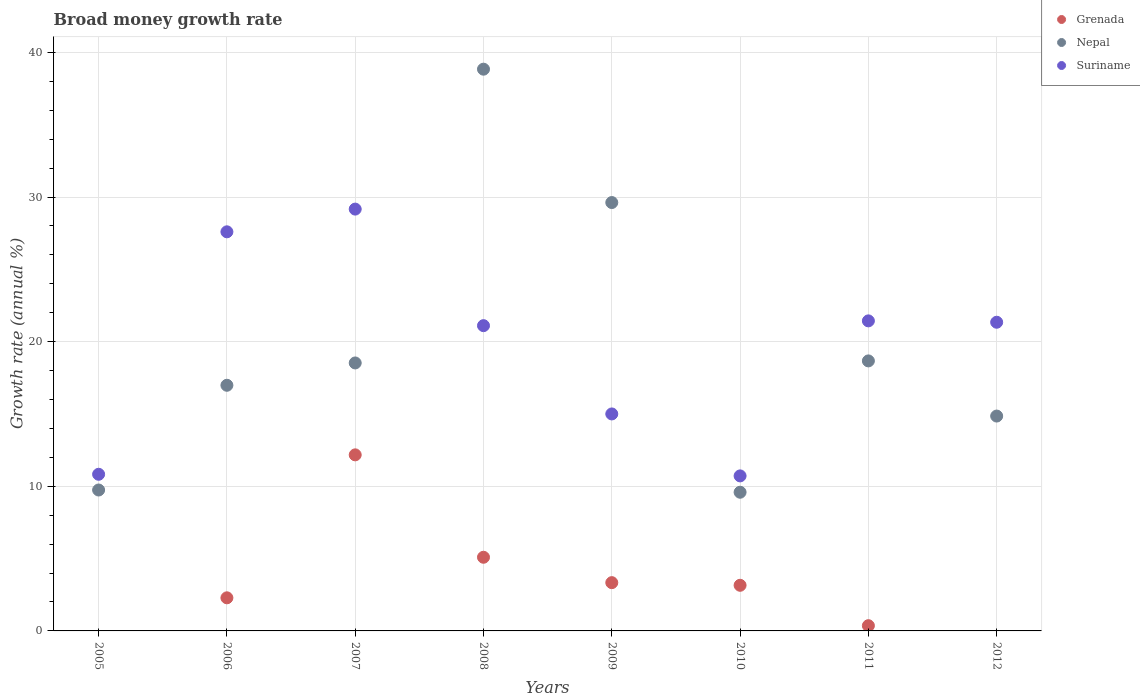Is the number of dotlines equal to the number of legend labels?
Offer a terse response. No. What is the growth rate in Nepal in 2005?
Provide a succinct answer. 9.74. Across all years, what is the maximum growth rate in Grenada?
Provide a short and direct response. 12.17. Across all years, what is the minimum growth rate in Grenada?
Keep it short and to the point. 0. In which year was the growth rate in Suriname maximum?
Offer a terse response. 2007. What is the total growth rate in Nepal in the graph?
Your answer should be compact. 156.83. What is the difference between the growth rate in Suriname in 2008 and that in 2009?
Make the answer very short. 6.1. What is the difference between the growth rate in Suriname in 2006 and the growth rate in Nepal in 2012?
Your answer should be compact. 12.74. What is the average growth rate in Suriname per year?
Keep it short and to the point. 19.65. In the year 2008, what is the difference between the growth rate in Suriname and growth rate in Grenada?
Your answer should be very brief. 16.01. In how many years, is the growth rate in Grenada greater than 20 %?
Ensure brevity in your answer.  0. What is the ratio of the growth rate in Suriname in 2007 to that in 2010?
Keep it short and to the point. 2.72. Is the growth rate in Nepal in 2005 less than that in 2012?
Ensure brevity in your answer.  Yes. What is the difference between the highest and the second highest growth rate in Nepal?
Provide a succinct answer. 9.22. What is the difference between the highest and the lowest growth rate in Grenada?
Your answer should be very brief. 12.17. In how many years, is the growth rate in Grenada greater than the average growth rate in Grenada taken over all years?
Your answer should be compact. 3. Is the sum of the growth rate in Grenada in 2007 and 2011 greater than the maximum growth rate in Suriname across all years?
Your answer should be very brief. No. Is it the case that in every year, the sum of the growth rate in Nepal and growth rate in Suriname  is greater than the growth rate in Grenada?
Your answer should be very brief. Yes. Does the growth rate in Nepal monotonically increase over the years?
Offer a terse response. No. Is the growth rate in Nepal strictly greater than the growth rate in Grenada over the years?
Give a very brief answer. Yes. Does the graph contain any zero values?
Your response must be concise. Yes. Where does the legend appear in the graph?
Provide a short and direct response. Top right. How many legend labels are there?
Your answer should be compact. 3. How are the legend labels stacked?
Offer a very short reply. Vertical. What is the title of the graph?
Your answer should be compact. Broad money growth rate. What is the label or title of the X-axis?
Offer a terse response. Years. What is the label or title of the Y-axis?
Your answer should be compact. Growth rate (annual %). What is the Growth rate (annual %) in Grenada in 2005?
Provide a short and direct response. 0. What is the Growth rate (annual %) in Nepal in 2005?
Give a very brief answer. 9.74. What is the Growth rate (annual %) of Suriname in 2005?
Offer a terse response. 10.83. What is the Growth rate (annual %) in Grenada in 2006?
Ensure brevity in your answer.  2.29. What is the Growth rate (annual %) in Nepal in 2006?
Ensure brevity in your answer.  16.99. What is the Growth rate (annual %) of Suriname in 2006?
Give a very brief answer. 27.6. What is the Growth rate (annual %) in Grenada in 2007?
Offer a very short reply. 12.17. What is the Growth rate (annual %) in Nepal in 2007?
Offer a terse response. 18.53. What is the Growth rate (annual %) of Suriname in 2007?
Your response must be concise. 29.17. What is the Growth rate (annual %) of Grenada in 2008?
Give a very brief answer. 5.09. What is the Growth rate (annual %) of Nepal in 2008?
Your answer should be very brief. 38.84. What is the Growth rate (annual %) of Suriname in 2008?
Your answer should be very brief. 21.11. What is the Growth rate (annual %) in Grenada in 2009?
Make the answer very short. 3.34. What is the Growth rate (annual %) in Nepal in 2009?
Your answer should be very brief. 29.62. What is the Growth rate (annual %) in Suriname in 2009?
Provide a succinct answer. 15. What is the Growth rate (annual %) in Grenada in 2010?
Your response must be concise. 3.15. What is the Growth rate (annual %) in Nepal in 2010?
Make the answer very short. 9.59. What is the Growth rate (annual %) of Suriname in 2010?
Make the answer very short. 10.72. What is the Growth rate (annual %) of Grenada in 2011?
Your answer should be compact. 0.36. What is the Growth rate (annual %) in Nepal in 2011?
Your answer should be compact. 18.67. What is the Growth rate (annual %) in Suriname in 2011?
Offer a very short reply. 21.44. What is the Growth rate (annual %) in Nepal in 2012?
Ensure brevity in your answer.  14.86. What is the Growth rate (annual %) of Suriname in 2012?
Your answer should be very brief. 21.34. Across all years, what is the maximum Growth rate (annual %) of Grenada?
Your answer should be compact. 12.17. Across all years, what is the maximum Growth rate (annual %) in Nepal?
Your answer should be compact. 38.84. Across all years, what is the maximum Growth rate (annual %) of Suriname?
Your answer should be very brief. 29.17. Across all years, what is the minimum Growth rate (annual %) of Grenada?
Ensure brevity in your answer.  0. Across all years, what is the minimum Growth rate (annual %) of Nepal?
Offer a terse response. 9.59. Across all years, what is the minimum Growth rate (annual %) of Suriname?
Provide a succinct answer. 10.72. What is the total Growth rate (annual %) of Grenada in the graph?
Ensure brevity in your answer.  26.41. What is the total Growth rate (annual %) of Nepal in the graph?
Your answer should be compact. 156.83. What is the total Growth rate (annual %) in Suriname in the graph?
Provide a succinct answer. 157.2. What is the difference between the Growth rate (annual %) of Nepal in 2005 and that in 2006?
Your answer should be very brief. -7.24. What is the difference between the Growth rate (annual %) in Suriname in 2005 and that in 2006?
Make the answer very short. -16.76. What is the difference between the Growth rate (annual %) in Nepal in 2005 and that in 2007?
Your answer should be very brief. -8.79. What is the difference between the Growth rate (annual %) in Suriname in 2005 and that in 2007?
Your answer should be very brief. -18.34. What is the difference between the Growth rate (annual %) in Nepal in 2005 and that in 2008?
Give a very brief answer. -29.1. What is the difference between the Growth rate (annual %) in Suriname in 2005 and that in 2008?
Offer a very short reply. -10.28. What is the difference between the Growth rate (annual %) of Nepal in 2005 and that in 2009?
Keep it short and to the point. -19.88. What is the difference between the Growth rate (annual %) in Suriname in 2005 and that in 2009?
Your answer should be very brief. -4.17. What is the difference between the Growth rate (annual %) in Nepal in 2005 and that in 2010?
Keep it short and to the point. 0.15. What is the difference between the Growth rate (annual %) in Suriname in 2005 and that in 2010?
Ensure brevity in your answer.  0.11. What is the difference between the Growth rate (annual %) of Nepal in 2005 and that in 2011?
Ensure brevity in your answer.  -8.93. What is the difference between the Growth rate (annual %) in Suriname in 2005 and that in 2011?
Your answer should be very brief. -10.61. What is the difference between the Growth rate (annual %) of Nepal in 2005 and that in 2012?
Provide a succinct answer. -5.11. What is the difference between the Growth rate (annual %) in Suriname in 2005 and that in 2012?
Provide a succinct answer. -10.51. What is the difference between the Growth rate (annual %) of Grenada in 2006 and that in 2007?
Give a very brief answer. -9.88. What is the difference between the Growth rate (annual %) in Nepal in 2006 and that in 2007?
Ensure brevity in your answer.  -1.54. What is the difference between the Growth rate (annual %) of Suriname in 2006 and that in 2007?
Your answer should be compact. -1.57. What is the difference between the Growth rate (annual %) of Grenada in 2006 and that in 2008?
Your answer should be compact. -2.8. What is the difference between the Growth rate (annual %) in Nepal in 2006 and that in 2008?
Make the answer very short. -21.86. What is the difference between the Growth rate (annual %) of Suriname in 2006 and that in 2008?
Provide a short and direct response. 6.49. What is the difference between the Growth rate (annual %) of Grenada in 2006 and that in 2009?
Your answer should be compact. -1.05. What is the difference between the Growth rate (annual %) of Nepal in 2006 and that in 2009?
Give a very brief answer. -12.63. What is the difference between the Growth rate (annual %) in Suriname in 2006 and that in 2009?
Give a very brief answer. 12.59. What is the difference between the Growth rate (annual %) in Grenada in 2006 and that in 2010?
Provide a succinct answer. -0.87. What is the difference between the Growth rate (annual %) in Nepal in 2006 and that in 2010?
Make the answer very short. 7.4. What is the difference between the Growth rate (annual %) in Suriname in 2006 and that in 2010?
Give a very brief answer. 16.88. What is the difference between the Growth rate (annual %) in Grenada in 2006 and that in 2011?
Provide a short and direct response. 1.93. What is the difference between the Growth rate (annual %) in Nepal in 2006 and that in 2011?
Give a very brief answer. -1.69. What is the difference between the Growth rate (annual %) in Suriname in 2006 and that in 2011?
Provide a succinct answer. 6.16. What is the difference between the Growth rate (annual %) of Nepal in 2006 and that in 2012?
Your response must be concise. 2.13. What is the difference between the Growth rate (annual %) in Suriname in 2006 and that in 2012?
Your response must be concise. 6.25. What is the difference between the Growth rate (annual %) of Grenada in 2007 and that in 2008?
Provide a short and direct response. 7.08. What is the difference between the Growth rate (annual %) of Nepal in 2007 and that in 2008?
Give a very brief answer. -20.31. What is the difference between the Growth rate (annual %) in Suriname in 2007 and that in 2008?
Your response must be concise. 8.06. What is the difference between the Growth rate (annual %) in Grenada in 2007 and that in 2009?
Provide a succinct answer. 8.84. What is the difference between the Growth rate (annual %) in Nepal in 2007 and that in 2009?
Offer a very short reply. -11.09. What is the difference between the Growth rate (annual %) in Suriname in 2007 and that in 2009?
Provide a succinct answer. 14.16. What is the difference between the Growth rate (annual %) in Grenada in 2007 and that in 2010?
Your answer should be very brief. 9.02. What is the difference between the Growth rate (annual %) in Nepal in 2007 and that in 2010?
Your answer should be compact. 8.94. What is the difference between the Growth rate (annual %) in Suriname in 2007 and that in 2010?
Give a very brief answer. 18.45. What is the difference between the Growth rate (annual %) of Grenada in 2007 and that in 2011?
Your answer should be compact. 11.81. What is the difference between the Growth rate (annual %) in Nepal in 2007 and that in 2011?
Your answer should be very brief. -0.14. What is the difference between the Growth rate (annual %) in Suriname in 2007 and that in 2011?
Provide a short and direct response. 7.73. What is the difference between the Growth rate (annual %) in Nepal in 2007 and that in 2012?
Your answer should be compact. 3.67. What is the difference between the Growth rate (annual %) of Suriname in 2007 and that in 2012?
Make the answer very short. 7.82. What is the difference between the Growth rate (annual %) of Grenada in 2008 and that in 2009?
Make the answer very short. 1.76. What is the difference between the Growth rate (annual %) of Nepal in 2008 and that in 2009?
Keep it short and to the point. 9.22. What is the difference between the Growth rate (annual %) in Suriname in 2008 and that in 2009?
Offer a very short reply. 6.1. What is the difference between the Growth rate (annual %) of Grenada in 2008 and that in 2010?
Make the answer very short. 1.94. What is the difference between the Growth rate (annual %) of Nepal in 2008 and that in 2010?
Your answer should be very brief. 29.25. What is the difference between the Growth rate (annual %) of Suriname in 2008 and that in 2010?
Ensure brevity in your answer.  10.39. What is the difference between the Growth rate (annual %) in Grenada in 2008 and that in 2011?
Provide a succinct answer. 4.73. What is the difference between the Growth rate (annual %) in Nepal in 2008 and that in 2011?
Offer a very short reply. 20.17. What is the difference between the Growth rate (annual %) of Suriname in 2008 and that in 2011?
Offer a terse response. -0.33. What is the difference between the Growth rate (annual %) in Nepal in 2008 and that in 2012?
Your answer should be very brief. 23.98. What is the difference between the Growth rate (annual %) of Suriname in 2008 and that in 2012?
Make the answer very short. -0.24. What is the difference between the Growth rate (annual %) of Grenada in 2009 and that in 2010?
Offer a terse response. 0.18. What is the difference between the Growth rate (annual %) in Nepal in 2009 and that in 2010?
Your response must be concise. 20.03. What is the difference between the Growth rate (annual %) of Suriname in 2009 and that in 2010?
Offer a terse response. 4.28. What is the difference between the Growth rate (annual %) in Grenada in 2009 and that in 2011?
Offer a very short reply. 2.98. What is the difference between the Growth rate (annual %) of Nepal in 2009 and that in 2011?
Offer a very short reply. 10.95. What is the difference between the Growth rate (annual %) in Suriname in 2009 and that in 2011?
Offer a very short reply. -6.43. What is the difference between the Growth rate (annual %) of Nepal in 2009 and that in 2012?
Offer a very short reply. 14.76. What is the difference between the Growth rate (annual %) of Suriname in 2009 and that in 2012?
Keep it short and to the point. -6.34. What is the difference between the Growth rate (annual %) of Grenada in 2010 and that in 2011?
Ensure brevity in your answer.  2.79. What is the difference between the Growth rate (annual %) in Nepal in 2010 and that in 2011?
Provide a short and direct response. -9.08. What is the difference between the Growth rate (annual %) in Suriname in 2010 and that in 2011?
Your response must be concise. -10.72. What is the difference between the Growth rate (annual %) in Nepal in 2010 and that in 2012?
Provide a short and direct response. -5.27. What is the difference between the Growth rate (annual %) of Suriname in 2010 and that in 2012?
Provide a short and direct response. -10.62. What is the difference between the Growth rate (annual %) of Nepal in 2011 and that in 2012?
Keep it short and to the point. 3.81. What is the difference between the Growth rate (annual %) of Suriname in 2011 and that in 2012?
Offer a terse response. 0.09. What is the difference between the Growth rate (annual %) of Nepal in 2005 and the Growth rate (annual %) of Suriname in 2006?
Your response must be concise. -17.85. What is the difference between the Growth rate (annual %) of Nepal in 2005 and the Growth rate (annual %) of Suriname in 2007?
Offer a very short reply. -19.42. What is the difference between the Growth rate (annual %) of Nepal in 2005 and the Growth rate (annual %) of Suriname in 2008?
Make the answer very short. -11.36. What is the difference between the Growth rate (annual %) in Nepal in 2005 and the Growth rate (annual %) in Suriname in 2009?
Keep it short and to the point. -5.26. What is the difference between the Growth rate (annual %) of Nepal in 2005 and the Growth rate (annual %) of Suriname in 2010?
Your answer should be very brief. -0.98. What is the difference between the Growth rate (annual %) in Nepal in 2005 and the Growth rate (annual %) in Suriname in 2011?
Provide a short and direct response. -11.69. What is the difference between the Growth rate (annual %) of Nepal in 2005 and the Growth rate (annual %) of Suriname in 2012?
Give a very brief answer. -11.6. What is the difference between the Growth rate (annual %) of Grenada in 2006 and the Growth rate (annual %) of Nepal in 2007?
Offer a terse response. -16.24. What is the difference between the Growth rate (annual %) of Grenada in 2006 and the Growth rate (annual %) of Suriname in 2007?
Your answer should be very brief. -26.88. What is the difference between the Growth rate (annual %) of Nepal in 2006 and the Growth rate (annual %) of Suriname in 2007?
Provide a succinct answer. -12.18. What is the difference between the Growth rate (annual %) of Grenada in 2006 and the Growth rate (annual %) of Nepal in 2008?
Ensure brevity in your answer.  -36.55. What is the difference between the Growth rate (annual %) of Grenada in 2006 and the Growth rate (annual %) of Suriname in 2008?
Ensure brevity in your answer.  -18.82. What is the difference between the Growth rate (annual %) of Nepal in 2006 and the Growth rate (annual %) of Suriname in 2008?
Offer a very short reply. -4.12. What is the difference between the Growth rate (annual %) of Grenada in 2006 and the Growth rate (annual %) of Nepal in 2009?
Your response must be concise. -27.33. What is the difference between the Growth rate (annual %) in Grenada in 2006 and the Growth rate (annual %) in Suriname in 2009?
Provide a short and direct response. -12.71. What is the difference between the Growth rate (annual %) in Nepal in 2006 and the Growth rate (annual %) in Suriname in 2009?
Make the answer very short. 1.98. What is the difference between the Growth rate (annual %) of Grenada in 2006 and the Growth rate (annual %) of Nepal in 2010?
Offer a very short reply. -7.3. What is the difference between the Growth rate (annual %) in Grenada in 2006 and the Growth rate (annual %) in Suriname in 2010?
Your answer should be very brief. -8.43. What is the difference between the Growth rate (annual %) in Nepal in 2006 and the Growth rate (annual %) in Suriname in 2010?
Offer a terse response. 6.27. What is the difference between the Growth rate (annual %) in Grenada in 2006 and the Growth rate (annual %) in Nepal in 2011?
Keep it short and to the point. -16.38. What is the difference between the Growth rate (annual %) of Grenada in 2006 and the Growth rate (annual %) of Suriname in 2011?
Make the answer very short. -19.15. What is the difference between the Growth rate (annual %) of Nepal in 2006 and the Growth rate (annual %) of Suriname in 2011?
Ensure brevity in your answer.  -4.45. What is the difference between the Growth rate (annual %) of Grenada in 2006 and the Growth rate (annual %) of Nepal in 2012?
Offer a terse response. -12.57. What is the difference between the Growth rate (annual %) of Grenada in 2006 and the Growth rate (annual %) of Suriname in 2012?
Your answer should be compact. -19.05. What is the difference between the Growth rate (annual %) in Nepal in 2006 and the Growth rate (annual %) in Suriname in 2012?
Keep it short and to the point. -4.36. What is the difference between the Growth rate (annual %) of Grenada in 2007 and the Growth rate (annual %) of Nepal in 2008?
Your answer should be compact. -26.67. What is the difference between the Growth rate (annual %) of Grenada in 2007 and the Growth rate (annual %) of Suriname in 2008?
Give a very brief answer. -8.93. What is the difference between the Growth rate (annual %) of Nepal in 2007 and the Growth rate (annual %) of Suriname in 2008?
Offer a terse response. -2.58. What is the difference between the Growth rate (annual %) of Grenada in 2007 and the Growth rate (annual %) of Nepal in 2009?
Provide a succinct answer. -17.45. What is the difference between the Growth rate (annual %) in Grenada in 2007 and the Growth rate (annual %) in Suriname in 2009?
Your response must be concise. -2.83. What is the difference between the Growth rate (annual %) in Nepal in 2007 and the Growth rate (annual %) in Suriname in 2009?
Provide a short and direct response. 3.53. What is the difference between the Growth rate (annual %) of Grenada in 2007 and the Growth rate (annual %) of Nepal in 2010?
Ensure brevity in your answer.  2.58. What is the difference between the Growth rate (annual %) of Grenada in 2007 and the Growth rate (annual %) of Suriname in 2010?
Keep it short and to the point. 1.45. What is the difference between the Growth rate (annual %) of Nepal in 2007 and the Growth rate (annual %) of Suriname in 2010?
Make the answer very short. 7.81. What is the difference between the Growth rate (annual %) of Grenada in 2007 and the Growth rate (annual %) of Nepal in 2011?
Provide a short and direct response. -6.5. What is the difference between the Growth rate (annual %) in Grenada in 2007 and the Growth rate (annual %) in Suriname in 2011?
Keep it short and to the point. -9.26. What is the difference between the Growth rate (annual %) in Nepal in 2007 and the Growth rate (annual %) in Suriname in 2011?
Provide a succinct answer. -2.91. What is the difference between the Growth rate (annual %) of Grenada in 2007 and the Growth rate (annual %) of Nepal in 2012?
Give a very brief answer. -2.68. What is the difference between the Growth rate (annual %) in Grenada in 2007 and the Growth rate (annual %) in Suriname in 2012?
Your answer should be compact. -9.17. What is the difference between the Growth rate (annual %) in Nepal in 2007 and the Growth rate (annual %) in Suriname in 2012?
Offer a very short reply. -2.81. What is the difference between the Growth rate (annual %) in Grenada in 2008 and the Growth rate (annual %) in Nepal in 2009?
Your answer should be compact. -24.53. What is the difference between the Growth rate (annual %) in Grenada in 2008 and the Growth rate (annual %) in Suriname in 2009?
Provide a short and direct response. -9.91. What is the difference between the Growth rate (annual %) of Nepal in 2008 and the Growth rate (annual %) of Suriname in 2009?
Ensure brevity in your answer.  23.84. What is the difference between the Growth rate (annual %) in Grenada in 2008 and the Growth rate (annual %) in Nepal in 2010?
Ensure brevity in your answer.  -4.5. What is the difference between the Growth rate (annual %) in Grenada in 2008 and the Growth rate (annual %) in Suriname in 2010?
Provide a short and direct response. -5.63. What is the difference between the Growth rate (annual %) of Nepal in 2008 and the Growth rate (annual %) of Suriname in 2010?
Ensure brevity in your answer.  28.12. What is the difference between the Growth rate (annual %) of Grenada in 2008 and the Growth rate (annual %) of Nepal in 2011?
Your answer should be compact. -13.58. What is the difference between the Growth rate (annual %) in Grenada in 2008 and the Growth rate (annual %) in Suriname in 2011?
Provide a succinct answer. -16.34. What is the difference between the Growth rate (annual %) in Nepal in 2008 and the Growth rate (annual %) in Suriname in 2011?
Keep it short and to the point. 17.4. What is the difference between the Growth rate (annual %) in Grenada in 2008 and the Growth rate (annual %) in Nepal in 2012?
Your answer should be compact. -9.76. What is the difference between the Growth rate (annual %) in Grenada in 2008 and the Growth rate (annual %) in Suriname in 2012?
Give a very brief answer. -16.25. What is the difference between the Growth rate (annual %) in Nepal in 2008 and the Growth rate (annual %) in Suriname in 2012?
Offer a terse response. 17.5. What is the difference between the Growth rate (annual %) of Grenada in 2009 and the Growth rate (annual %) of Nepal in 2010?
Ensure brevity in your answer.  -6.25. What is the difference between the Growth rate (annual %) in Grenada in 2009 and the Growth rate (annual %) in Suriname in 2010?
Offer a terse response. -7.38. What is the difference between the Growth rate (annual %) of Nepal in 2009 and the Growth rate (annual %) of Suriname in 2010?
Make the answer very short. 18.9. What is the difference between the Growth rate (annual %) in Grenada in 2009 and the Growth rate (annual %) in Nepal in 2011?
Ensure brevity in your answer.  -15.33. What is the difference between the Growth rate (annual %) of Grenada in 2009 and the Growth rate (annual %) of Suriname in 2011?
Your response must be concise. -18.1. What is the difference between the Growth rate (annual %) of Nepal in 2009 and the Growth rate (annual %) of Suriname in 2011?
Provide a short and direct response. 8.18. What is the difference between the Growth rate (annual %) in Grenada in 2009 and the Growth rate (annual %) in Nepal in 2012?
Offer a very short reply. -11.52. What is the difference between the Growth rate (annual %) in Grenada in 2009 and the Growth rate (annual %) in Suriname in 2012?
Your answer should be very brief. -18.01. What is the difference between the Growth rate (annual %) of Nepal in 2009 and the Growth rate (annual %) of Suriname in 2012?
Provide a succinct answer. 8.28. What is the difference between the Growth rate (annual %) of Grenada in 2010 and the Growth rate (annual %) of Nepal in 2011?
Your answer should be compact. -15.52. What is the difference between the Growth rate (annual %) of Grenada in 2010 and the Growth rate (annual %) of Suriname in 2011?
Ensure brevity in your answer.  -18.28. What is the difference between the Growth rate (annual %) of Nepal in 2010 and the Growth rate (annual %) of Suriname in 2011?
Provide a succinct answer. -11.85. What is the difference between the Growth rate (annual %) of Grenada in 2010 and the Growth rate (annual %) of Nepal in 2012?
Give a very brief answer. -11.7. What is the difference between the Growth rate (annual %) in Grenada in 2010 and the Growth rate (annual %) in Suriname in 2012?
Ensure brevity in your answer.  -18.19. What is the difference between the Growth rate (annual %) of Nepal in 2010 and the Growth rate (annual %) of Suriname in 2012?
Ensure brevity in your answer.  -11.75. What is the difference between the Growth rate (annual %) of Grenada in 2011 and the Growth rate (annual %) of Nepal in 2012?
Make the answer very short. -14.49. What is the difference between the Growth rate (annual %) in Grenada in 2011 and the Growth rate (annual %) in Suriname in 2012?
Offer a very short reply. -20.98. What is the difference between the Growth rate (annual %) of Nepal in 2011 and the Growth rate (annual %) of Suriname in 2012?
Offer a terse response. -2.67. What is the average Growth rate (annual %) in Grenada per year?
Keep it short and to the point. 3.3. What is the average Growth rate (annual %) in Nepal per year?
Offer a terse response. 19.6. What is the average Growth rate (annual %) of Suriname per year?
Provide a succinct answer. 19.65. In the year 2005, what is the difference between the Growth rate (annual %) in Nepal and Growth rate (annual %) in Suriname?
Your answer should be compact. -1.09. In the year 2006, what is the difference between the Growth rate (annual %) of Grenada and Growth rate (annual %) of Nepal?
Make the answer very short. -14.7. In the year 2006, what is the difference between the Growth rate (annual %) in Grenada and Growth rate (annual %) in Suriname?
Provide a succinct answer. -25.31. In the year 2006, what is the difference between the Growth rate (annual %) in Nepal and Growth rate (annual %) in Suriname?
Provide a succinct answer. -10.61. In the year 2007, what is the difference between the Growth rate (annual %) in Grenada and Growth rate (annual %) in Nepal?
Keep it short and to the point. -6.35. In the year 2007, what is the difference between the Growth rate (annual %) of Grenada and Growth rate (annual %) of Suriname?
Your answer should be very brief. -16.99. In the year 2007, what is the difference between the Growth rate (annual %) of Nepal and Growth rate (annual %) of Suriname?
Ensure brevity in your answer.  -10.64. In the year 2008, what is the difference between the Growth rate (annual %) in Grenada and Growth rate (annual %) in Nepal?
Keep it short and to the point. -33.75. In the year 2008, what is the difference between the Growth rate (annual %) of Grenada and Growth rate (annual %) of Suriname?
Make the answer very short. -16.01. In the year 2008, what is the difference between the Growth rate (annual %) in Nepal and Growth rate (annual %) in Suriname?
Provide a succinct answer. 17.73. In the year 2009, what is the difference between the Growth rate (annual %) of Grenada and Growth rate (annual %) of Nepal?
Your answer should be very brief. -26.28. In the year 2009, what is the difference between the Growth rate (annual %) of Grenada and Growth rate (annual %) of Suriname?
Offer a terse response. -11.67. In the year 2009, what is the difference between the Growth rate (annual %) in Nepal and Growth rate (annual %) in Suriname?
Provide a short and direct response. 14.62. In the year 2010, what is the difference between the Growth rate (annual %) of Grenada and Growth rate (annual %) of Nepal?
Your answer should be compact. -6.43. In the year 2010, what is the difference between the Growth rate (annual %) in Grenada and Growth rate (annual %) in Suriname?
Make the answer very short. -7.56. In the year 2010, what is the difference between the Growth rate (annual %) in Nepal and Growth rate (annual %) in Suriname?
Offer a terse response. -1.13. In the year 2011, what is the difference between the Growth rate (annual %) in Grenada and Growth rate (annual %) in Nepal?
Ensure brevity in your answer.  -18.31. In the year 2011, what is the difference between the Growth rate (annual %) in Grenada and Growth rate (annual %) in Suriname?
Make the answer very short. -21.08. In the year 2011, what is the difference between the Growth rate (annual %) in Nepal and Growth rate (annual %) in Suriname?
Make the answer very short. -2.77. In the year 2012, what is the difference between the Growth rate (annual %) in Nepal and Growth rate (annual %) in Suriname?
Provide a succinct answer. -6.49. What is the ratio of the Growth rate (annual %) in Nepal in 2005 to that in 2006?
Ensure brevity in your answer.  0.57. What is the ratio of the Growth rate (annual %) in Suriname in 2005 to that in 2006?
Your answer should be very brief. 0.39. What is the ratio of the Growth rate (annual %) in Nepal in 2005 to that in 2007?
Make the answer very short. 0.53. What is the ratio of the Growth rate (annual %) in Suriname in 2005 to that in 2007?
Ensure brevity in your answer.  0.37. What is the ratio of the Growth rate (annual %) of Nepal in 2005 to that in 2008?
Your answer should be very brief. 0.25. What is the ratio of the Growth rate (annual %) of Suriname in 2005 to that in 2008?
Your answer should be compact. 0.51. What is the ratio of the Growth rate (annual %) in Nepal in 2005 to that in 2009?
Your answer should be very brief. 0.33. What is the ratio of the Growth rate (annual %) of Suriname in 2005 to that in 2009?
Your answer should be very brief. 0.72. What is the ratio of the Growth rate (annual %) in Nepal in 2005 to that in 2010?
Provide a succinct answer. 1.02. What is the ratio of the Growth rate (annual %) of Suriname in 2005 to that in 2010?
Provide a short and direct response. 1.01. What is the ratio of the Growth rate (annual %) of Nepal in 2005 to that in 2011?
Make the answer very short. 0.52. What is the ratio of the Growth rate (annual %) in Suriname in 2005 to that in 2011?
Give a very brief answer. 0.51. What is the ratio of the Growth rate (annual %) of Nepal in 2005 to that in 2012?
Provide a succinct answer. 0.66. What is the ratio of the Growth rate (annual %) in Suriname in 2005 to that in 2012?
Your response must be concise. 0.51. What is the ratio of the Growth rate (annual %) in Grenada in 2006 to that in 2007?
Make the answer very short. 0.19. What is the ratio of the Growth rate (annual %) in Nepal in 2006 to that in 2007?
Offer a terse response. 0.92. What is the ratio of the Growth rate (annual %) in Suriname in 2006 to that in 2007?
Give a very brief answer. 0.95. What is the ratio of the Growth rate (annual %) of Grenada in 2006 to that in 2008?
Provide a succinct answer. 0.45. What is the ratio of the Growth rate (annual %) in Nepal in 2006 to that in 2008?
Keep it short and to the point. 0.44. What is the ratio of the Growth rate (annual %) in Suriname in 2006 to that in 2008?
Offer a very short reply. 1.31. What is the ratio of the Growth rate (annual %) in Grenada in 2006 to that in 2009?
Ensure brevity in your answer.  0.69. What is the ratio of the Growth rate (annual %) of Nepal in 2006 to that in 2009?
Ensure brevity in your answer.  0.57. What is the ratio of the Growth rate (annual %) in Suriname in 2006 to that in 2009?
Make the answer very short. 1.84. What is the ratio of the Growth rate (annual %) in Grenada in 2006 to that in 2010?
Offer a terse response. 0.73. What is the ratio of the Growth rate (annual %) of Nepal in 2006 to that in 2010?
Offer a very short reply. 1.77. What is the ratio of the Growth rate (annual %) of Suriname in 2006 to that in 2010?
Provide a succinct answer. 2.57. What is the ratio of the Growth rate (annual %) in Grenada in 2006 to that in 2011?
Your answer should be very brief. 6.32. What is the ratio of the Growth rate (annual %) of Nepal in 2006 to that in 2011?
Provide a short and direct response. 0.91. What is the ratio of the Growth rate (annual %) of Suriname in 2006 to that in 2011?
Offer a very short reply. 1.29. What is the ratio of the Growth rate (annual %) of Nepal in 2006 to that in 2012?
Your response must be concise. 1.14. What is the ratio of the Growth rate (annual %) of Suriname in 2006 to that in 2012?
Offer a very short reply. 1.29. What is the ratio of the Growth rate (annual %) of Grenada in 2007 to that in 2008?
Ensure brevity in your answer.  2.39. What is the ratio of the Growth rate (annual %) of Nepal in 2007 to that in 2008?
Provide a short and direct response. 0.48. What is the ratio of the Growth rate (annual %) in Suriname in 2007 to that in 2008?
Your answer should be very brief. 1.38. What is the ratio of the Growth rate (annual %) of Grenada in 2007 to that in 2009?
Ensure brevity in your answer.  3.65. What is the ratio of the Growth rate (annual %) in Nepal in 2007 to that in 2009?
Offer a terse response. 0.63. What is the ratio of the Growth rate (annual %) in Suriname in 2007 to that in 2009?
Offer a very short reply. 1.94. What is the ratio of the Growth rate (annual %) of Grenada in 2007 to that in 2010?
Ensure brevity in your answer.  3.86. What is the ratio of the Growth rate (annual %) in Nepal in 2007 to that in 2010?
Offer a terse response. 1.93. What is the ratio of the Growth rate (annual %) of Suriname in 2007 to that in 2010?
Give a very brief answer. 2.72. What is the ratio of the Growth rate (annual %) of Grenada in 2007 to that in 2011?
Your response must be concise. 33.63. What is the ratio of the Growth rate (annual %) in Nepal in 2007 to that in 2011?
Offer a very short reply. 0.99. What is the ratio of the Growth rate (annual %) of Suriname in 2007 to that in 2011?
Your answer should be very brief. 1.36. What is the ratio of the Growth rate (annual %) of Nepal in 2007 to that in 2012?
Your response must be concise. 1.25. What is the ratio of the Growth rate (annual %) of Suriname in 2007 to that in 2012?
Provide a succinct answer. 1.37. What is the ratio of the Growth rate (annual %) in Grenada in 2008 to that in 2009?
Ensure brevity in your answer.  1.53. What is the ratio of the Growth rate (annual %) of Nepal in 2008 to that in 2009?
Your answer should be compact. 1.31. What is the ratio of the Growth rate (annual %) of Suriname in 2008 to that in 2009?
Provide a succinct answer. 1.41. What is the ratio of the Growth rate (annual %) in Grenada in 2008 to that in 2010?
Make the answer very short. 1.61. What is the ratio of the Growth rate (annual %) of Nepal in 2008 to that in 2010?
Provide a succinct answer. 4.05. What is the ratio of the Growth rate (annual %) of Suriname in 2008 to that in 2010?
Provide a succinct answer. 1.97. What is the ratio of the Growth rate (annual %) of Grenada in 2008 to that in 2011?
Give a very brief answer. 14.07. What is the ratio of the Growth rate (annual %) of Nepal in 2008 to that in 2011?
Make the answer very short. 2.08. What is the ratio of the Growth rate (annual %) of Suriname in 2008 to that in 2011?
Keep it short and to the point. 0.98. What is the ratio of the Growth rate (annual %) in Nepal in 2008 to that in 2012?
Offer a terse response. 2.61. What is the ratio of the Growth rate (annual %) in Suriname in 2008 to that in 2012?
Make the answer very short. 0.99. What is the ratio of the Growth rate (annual %) in Grenada in 2009 to that in 2010?
Make the answer very short. 1.06. What is the ratio of the Growth rate (annual %) in Nepal in 2009 to that in 2010?
Your answer should be very brief. 3.09. What is the ratio of the Growth rate (annual %) in Suriname in 2009 to that in 2010?
Offer a very short reply. 1.4. What is the ratio of the Growth rate (annual %) of Grenada in 2009 to that in 2011?
Offer a very short reply. 9.22. What is the ratio of the Growth rate (annual %) in Nepal in 2009 to that in 2011?
Your response must be concise. 1.59. What is the ratio of the Growth rate (annual %) of Suriname in 2009 to that in 2011?
Your answer should be very brief. 0.7. What is the ratio of the Growth rate (annual %) of Nepal in 2009 to that in 2012?
Keep it short and to the point. 1.99. What is the ratio of the Growth rate (annual %) of Suriname in 2009 to that in 2012?
Make the answer very short. 0.7. What is the ratio of the Growth rate (annual %) of Grenada in 2010 to that in 2011?
Ensure brevity in your answer.  8.72. What is the ratio of the Growth rate (annual %) in Nepal in 2010 to that in 2011?
Ensure brevity in your answer.  0.51. What is the ratio of the Growth rate (annual %) of Suriname in 2010 to that in 2011?
Your answer should be very brief. 0.5. What is the ratio of the Growth rate (annual %) of Nepal in 2010 to that in 2012?
Ensure brevity in your answer.  0.65. What is the ratio of the Growth rate (annual %) of Suriname in 2010 to that in 2012?
Your answer should be compact. 0.5. What is the ratio of the Growth rate (annual %) of Nepal in 2011 to that in 2012?
Provide a short and direct response. 1.26. What is the ratio of the Growth rate (annual %) of Suriname in 2011 to that in 2012?
Ensure brevity in your answer.  1. What is the difference between the highest and the second highest Growth rate (annual %) of Grenada?
Offer a terse response. 7.08. What is the difference between the highest and the second highest Growth rate (annual %) in Nepal?
Offer a very short reply. 9.22. What is the difference between the highest and the second highest Growth rate (annual %) in Suriname?
Provide a short and direct response. 1.57. What is the difference between the highest and the lowest Growth rate (annual %) of Grenada?
Your response must be concise. 12.17. What is the difference between the highest and the lowest Growth rate (annual %) in Nepal?
Provide a short and direct response. 29.25. What is the difference between the highest and the lowest Growth rate (annual %) of Suriname?
Ensure brevity in your answer.  18.45. 